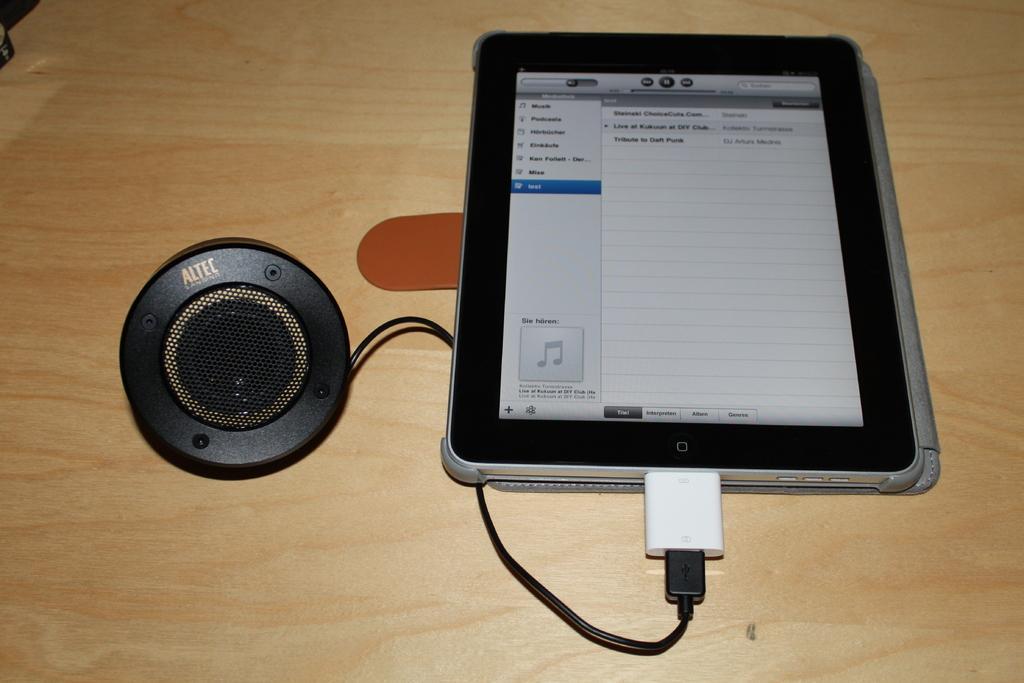In one or two sentences, can you explain what this image depicts? In this image, we can see an object with a cable is connected to a tab and at the bottom, there is a table. 